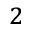Convert formula to latex. <formula><loc_0><loc_0><loc_500><loc_500>^ { 2 }</formula> 